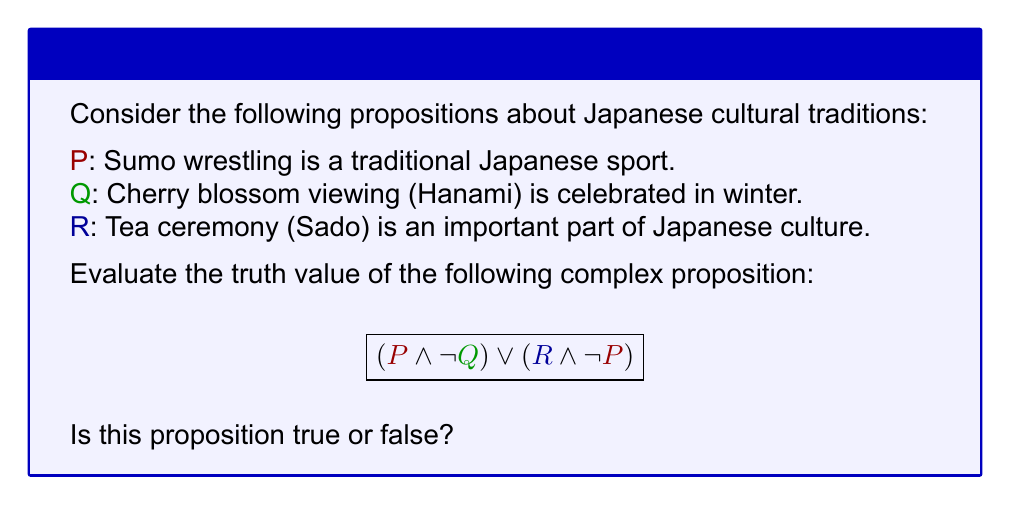Show me your answer to this math problem. Let's evaluate this step-by-step:

1. First, we need to determine the truth values of P, Q, and R:
   P: True (Sumo wrestling is indeed a traditional Japanese sport)
   Q: False (Cherry blossom viewing is celebrated in spring, not winter)
   R: True (Tea ceremony is an important part of Japanese culture)

2. Now, let's break down the complex proposition:
   $$(P \land \lnot Q) \lor (R \land \lnot P)$$

3. Evaluate $\lnot Q$:
   Q is false, so $\lnot Q$ is true

4. Evaluate $P \land \lnot Q$:
   P is true and $\lnot Q$ is true, so $P \land \lnot Q$ is true

5. Evaluate $\lnot P$:
   P is true, so $\lnot P$ is false

6. Evaluate $R \land \lnot P$:
   R is true and $\lnot P$ is false, so $R \land \lnot P$ is false

7. Finally, evaluate the entire proposition:
   $(P \land \lnot Q) \lor (R \land \lnot P)$
   This is equivalent to: true $\lor$ false

8. In propositional logic, true $\lor$ false evaluates to true

Therefore, the complex proposition is true.
Answer: True 